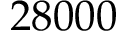Convert formula to latex. <formula><loc_0><loc_0><loc_500><loc_500>2 8 0 0 0</formula> 